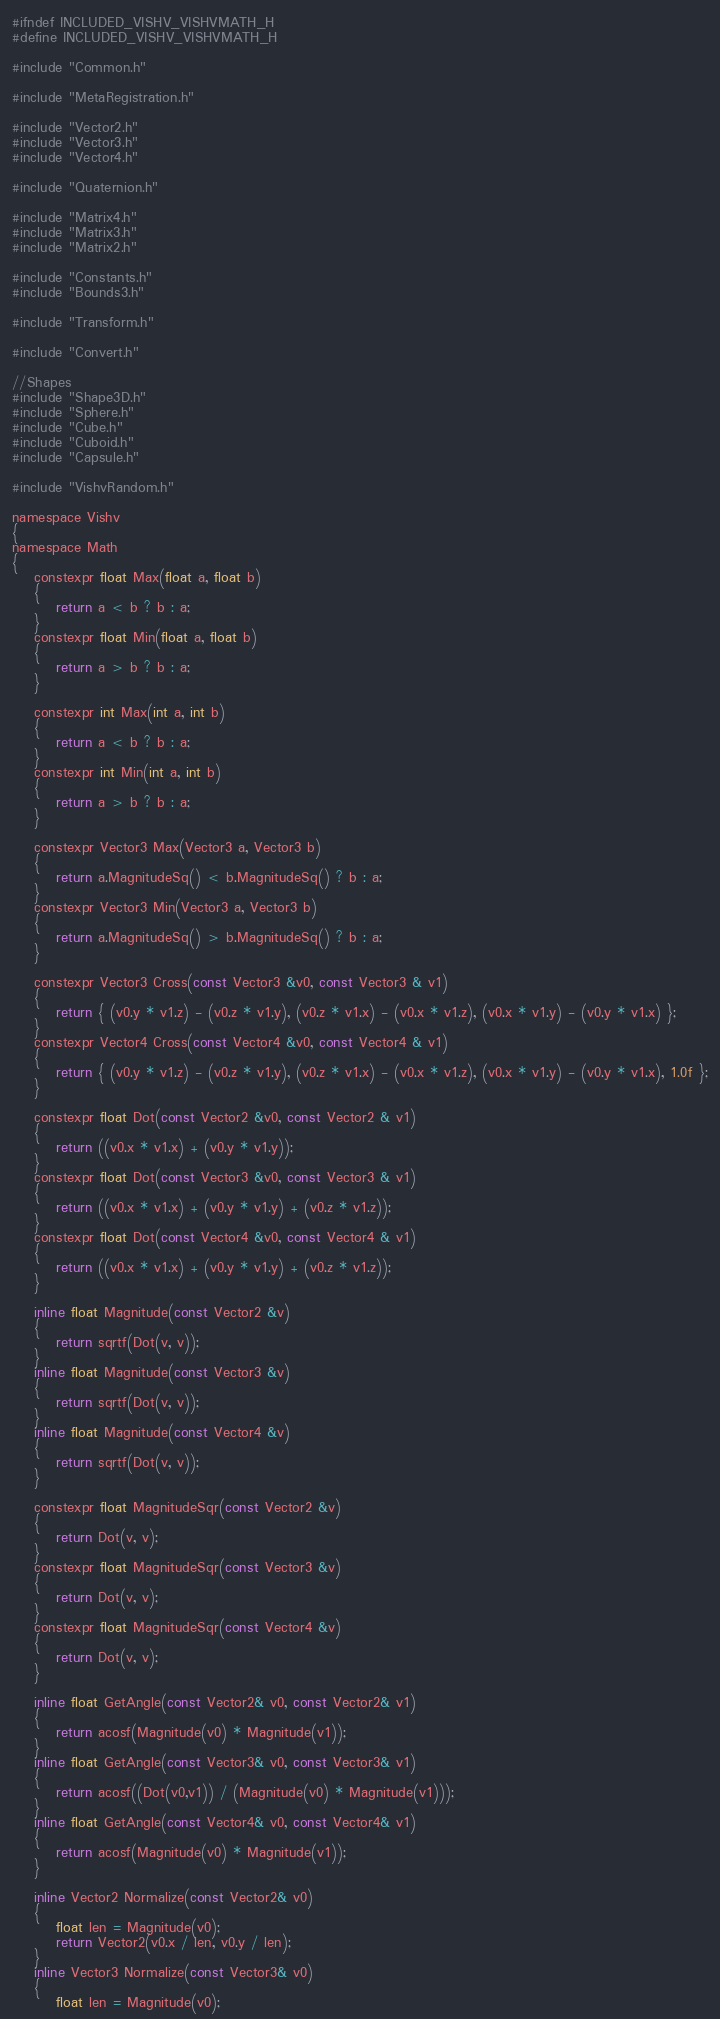<code> <loc_0><loc_0><loc_500><loc_500><_C_>#ifndef INCLUDED_VISHV_VISHVMATH_H
#define INCLUDED_VISHV_VISHVMATH_H

#include "Common.h"

#include "MetaRegistration.h"

#include "Vector2.h"
#include "Vector3.h"
#include "Vector4.h"

#include "Quaternion.h"

#include "Matrix4.h"
#include "Matrix3.h"
#include "Matrix2.h"

#include "Constants.h"
#include "Bounds3.h"

#include "Transform.h"

#include "Convert.h"

//Shapes
#include "Shape3D.h"
#include "Sphere.h"
#include "Cube.h"
#include "Cuboid.h"
#include "Capsule.h"

#include "VishvRandom.h"

namespace Vishv
{
namespace Math
{
	constexpr float Max(float a, float b)
	{
		return a < b ? b : a;
	}
	constexpr float Min(float a, float b)
	{
		return a > b ? b : a;
	}

	constexpr int Max(int a, int b)
	{
		return a < b ? b : a;
	}
	constexpr int Min(int a, int b)
	{
		return a > b ? b : a;
	}

	constexpr Vector3 Max(Vector3 a, Vector3 b)
	{
		return a.MagnitudeSq() < b.MagnitudeSq() ? b : a;
	}
	constexpr Vector3 Min(Vector3 a, Vector3 b)
	{
		return a.MagnitudeSq() > b.MagnitudeSq() ? b : a;
	}

	constexpr Vector3 Cross(const Vector3 &v0, const Vector3 & v1)
	{
		return { (v0.y * v1.z) - (v0.z * v1.y), (v0.z * v1.x) - (v0.x * v1.z), (v0.x * v1.y) - (v0.y * v1.x) };
	}
	constexpr Vector4 Cross(const Vector4 &v0, const Vector4 & v1)
	{
		return { (v0.y * v1.z) - (v0.z * v1.y), (v0.z * v1.x) - (v0.x * v1.z), (v0.x * v1.y) - (v0.y * v1.x), 1.0f };
	}

	constexpr float Dot(const Vector2 &v0, const Vector2 & v1)
	{
		return ((v0.x * v1.x) + (v0.y * v1.y));
	}
	constexpr float Dot(const Vector3 &v0, const Vector3 & v1)
	{
		return ((v0.x * v1.x) + (v0.y * v1.y) + (v0.z * v1.z));
	}
	constexpr float Dot(const Vector4 &v0, const Vector4 & v1)
	{
		return ((v0.x * v1.x) + (v0.y * v1.y) + (v0.z * v1.z));
	}

	inline float Magnitude(const Vector2 &v)
	{
		return sqrtf(Dot(v, v));
	}
	inline float Magnitude(const Vector3 &v)
	{
		return sqrtf(Dot(v, v));
	}
	inline float Magnitude(const Vector4 &v)
	{
		return sqrtf(Dot(v, v));
	}

	constexpr float MagnitudeSqr(const Vector2 &v)
	{
		return Dot(v, v);
	}
	constexpr float MagnitudeSqr(const Vector3 &v)
	{
		return Dot(v, v);
	}
	constexpr float MagnitudeSqr(const Vector4 &v)
	{
		return Dot(v, v);
	}

	inline float GetAngle(const Vector2& v0, const Vector2& v1)
	{
		return acosf(Magnitude(v0) * Magnitude(v1));
	}
	inline float GetAngle(const Vector3& v0, const Vector3& v1)
	{
		return acosf((Dot(v0,v1)) / (Magnitude(v0) * Magnitude(v1)));
	}
	inline float GetAngle(const Vector4& v0, const Vector4& v1)
	{
		return acosf(Magnitude(v0) * Magnitude(v1));
	}

	inline Vector2 Normalize(const Vector2& v0)
	{
		float len = Magnitude(v0);
		return Vector2(v0.x / len, v0.y / len);
	}
	inline Vector3 Normalize(const Vector3& v0)
	{
		float len = Magnitude(v0);</code> 